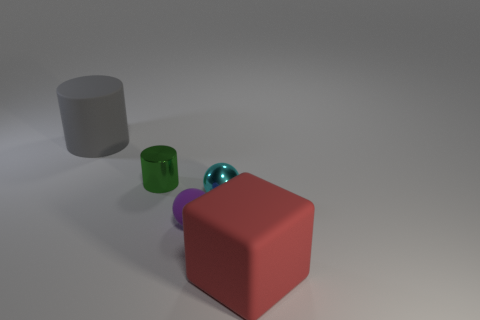Add 5 red cubes. How many objects exist? 10 Subtract all cylinders. How many objects are left? 3 Add 5 small metal objects. How many small metal objects are left? 7 Add 4 red shiny things. How many red shiny things exist? 4 Subtract 1 red blocks. How many objects are left? 4 Subtract all rubber balls. Subtract all gray cubes. How many objects are left? 4 